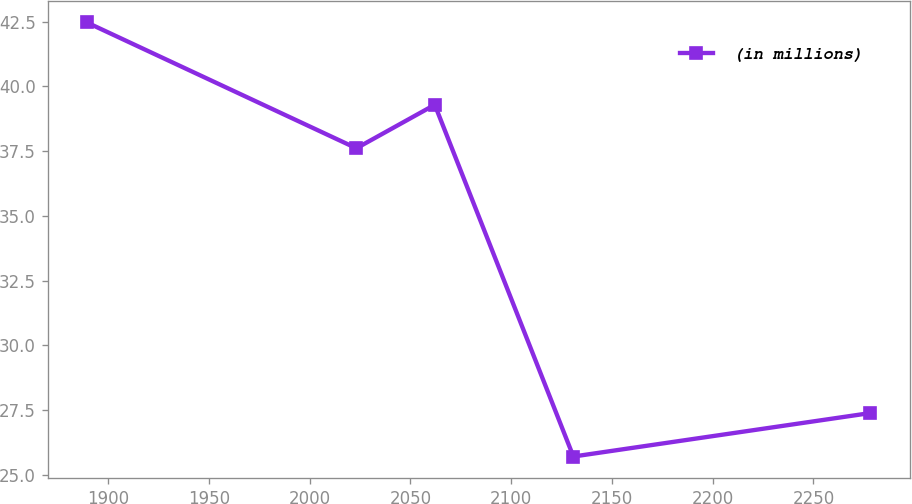Convert chart to OTSL. <chart><loc_0><loc_0><loc_500><loc_500><line_chart><ecel><fcel>(in millions)<nl><fcel>1889.38<fcel>42.47<nl><fcel>2023.16<fcel>37.61<nl><fcel>2062.05<fcel>39.29<nl><fcel>2130.85<fcel>25.7<nl><fcel>2278.27<fcel>27.38<nl></chart> 